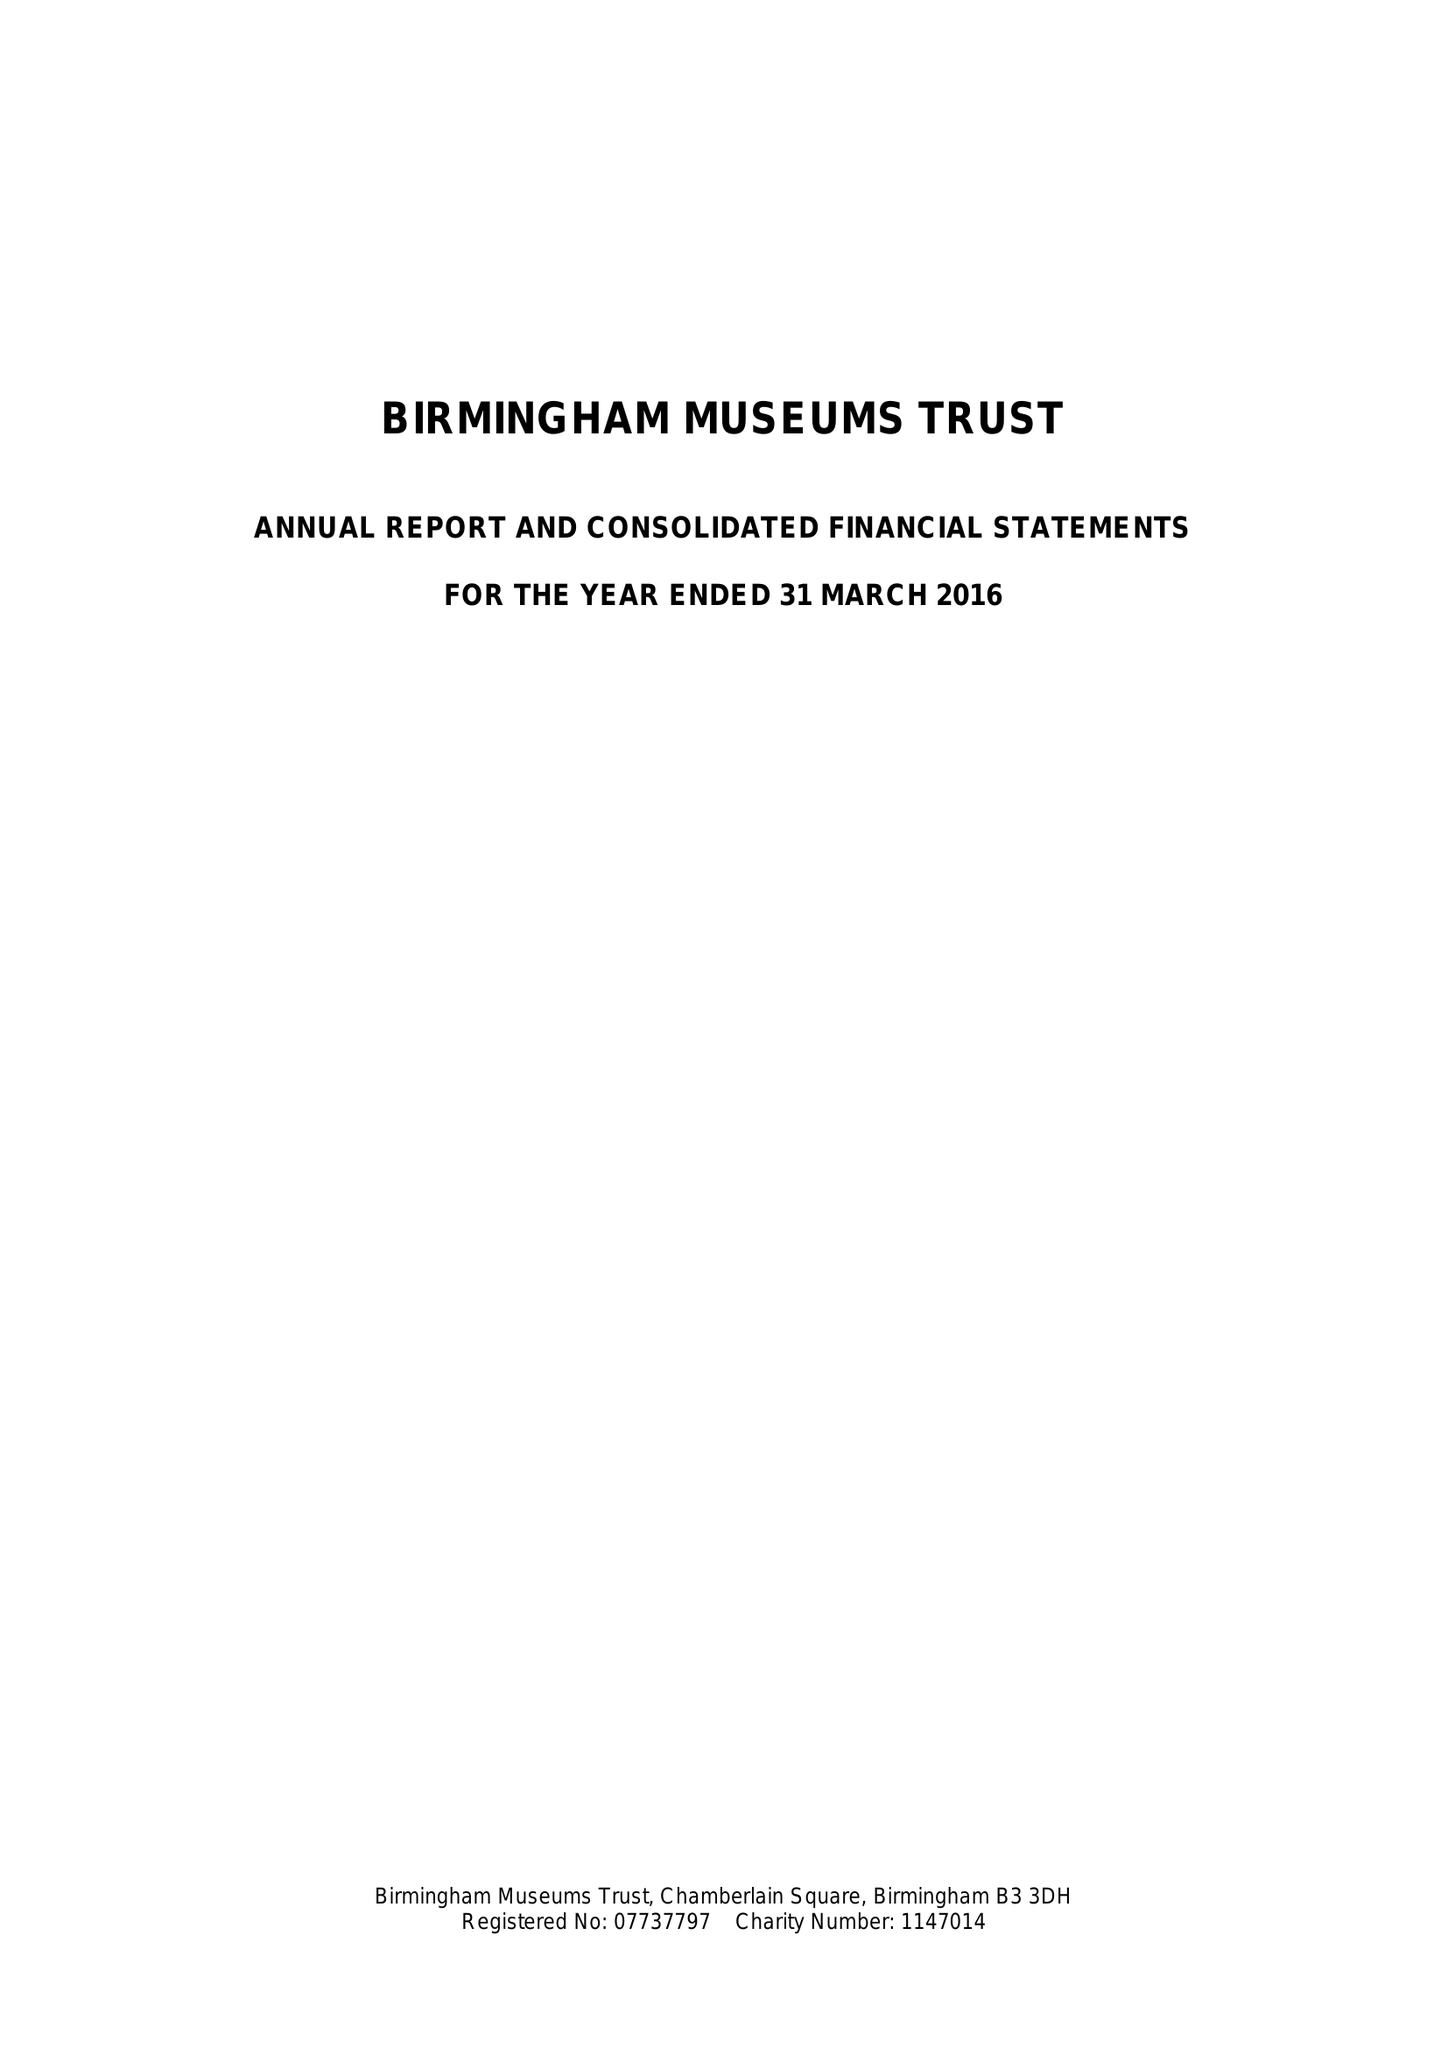What is the value for the address__post_town?
Answer the question using a single word or phrase. BIRMINGHAM 